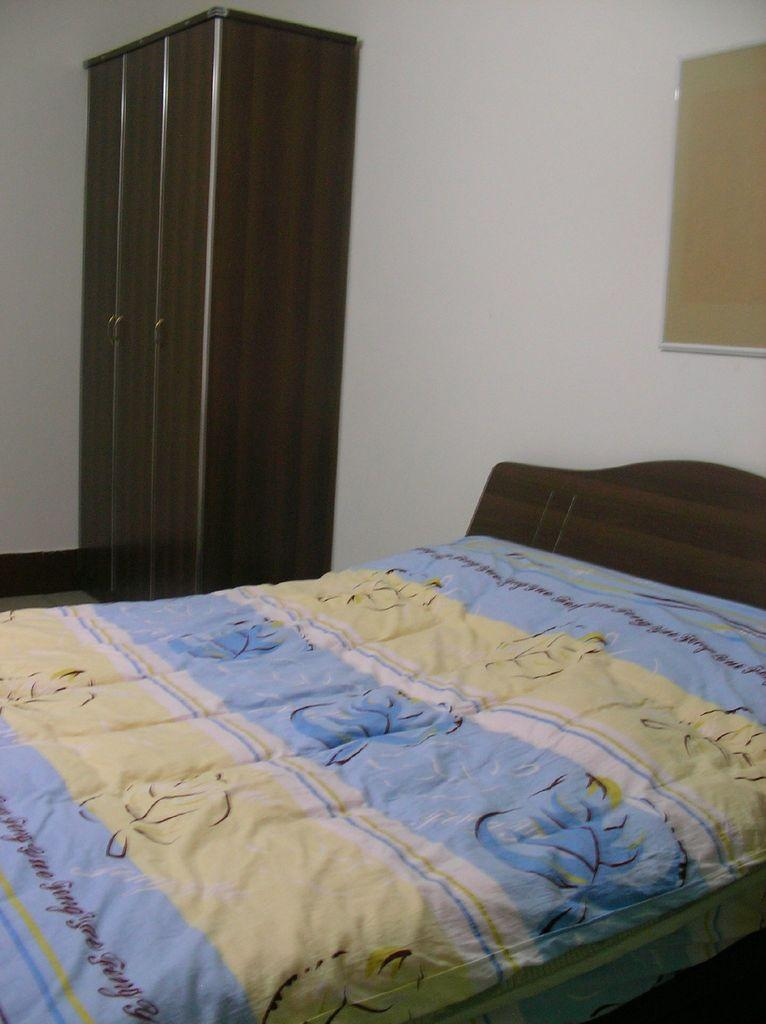What type of furniture is present in the image? There is a bed and a wardrobe in the image. What is covering the bed in the image? The bed has a blanket. Is there any other decorative or functional item attached to the wall in the image? Yes, there is a frame attached to the wall in the image. What type of scene is depicted in the frame on the wall? There is no scene depicted in the frame on the wall in the image, as the provided facts do not mention any artwork or decoration within the frame. 